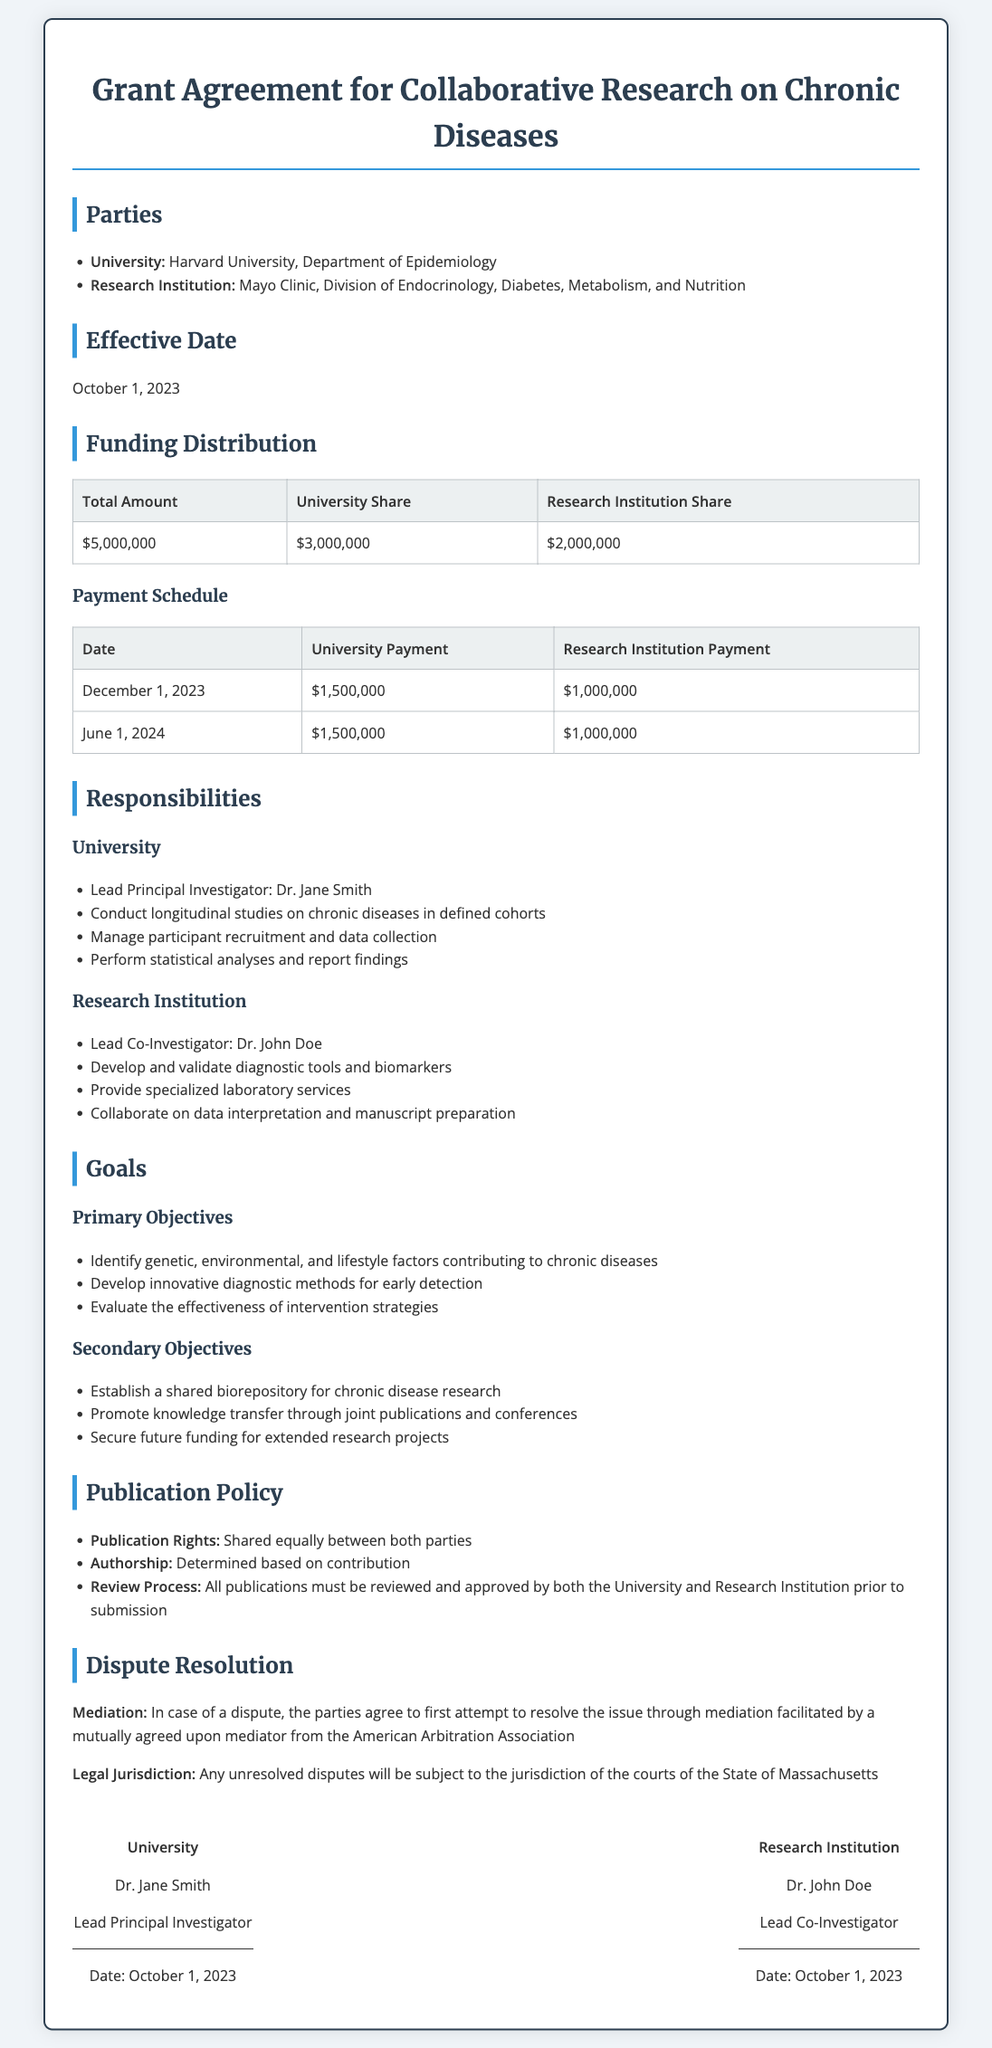What is the total funding amount? The total funding amount is explicitly stated in the document under the Funding Distribution section as $5,000,000.
Answer: $5,000,000 Who is the Lead Principal Investigator? The document specifies that the Lead Principal Investigator from the University is Dr. Jane Smith.
Answer: Dr. Jane Smith What is the payment date for the first installment? The first payment date listed in the Payment Schedule is December 1, 2023.
Answer: December 1, 2023 What is the share of the Research Institution? The Research Institution's share of the total funding is detailed in the Funding Distribution table as $2,000,000.
Answer: $2,000,000 What is one of the primary objectives of the research? The document outlines multiple primary objectives, one of which is to identify genetic, environmental, and lifestyle factors contributing to chronic diseases.
Answer: Identify genetic, environmental, and lifestyle factors contributing to chronic diseases Who is responsible for resolving disputes? The document states that disputes should be resolved through mediation facilitated by a mutually agreed upon mediator.
Answer: Mediation What date was the agreement signed? The document lists the date of signing as October 1, 2023, under the signature sections for both parties.
Answer: October 1, 2023 What laboratory services will the Research Institution provide? The Research Institution's responsibilities include providing specialized laboratory services, as stated in the responsibilities section.
Answer: Provide specialized laboratory services What are the publication rights as per the document? The publication rights are specified to be shared equally between both parties in the publication policy section.
Answer: Shared equally between both parties 